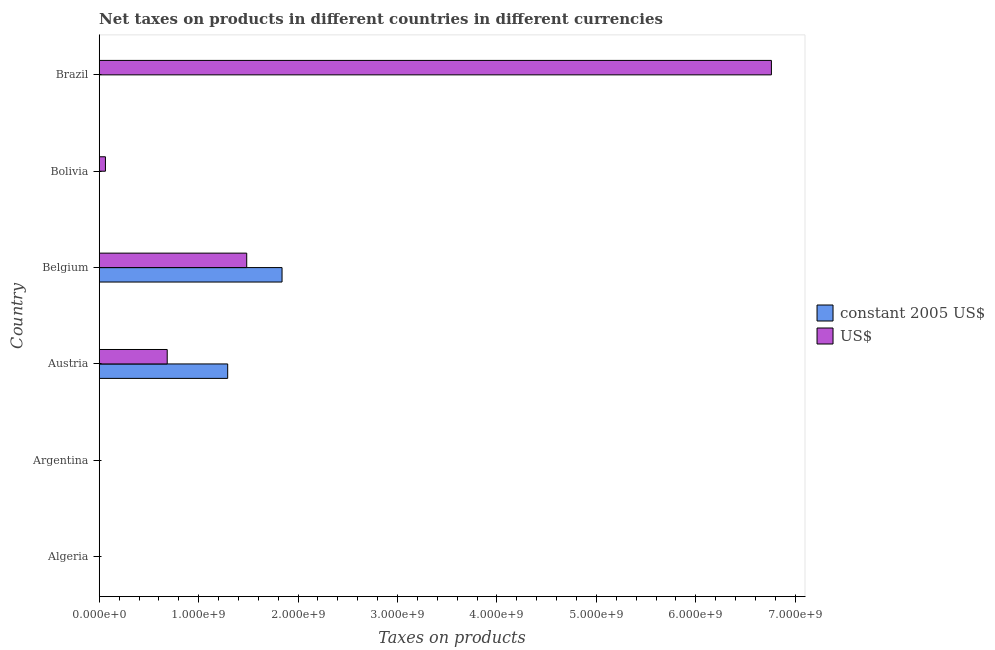Are the number of bars per tick equal to the number of legend labels?
Give a very brief answer. No. Are the number of bars on each tick of the Y-axis equal?
Offer a very short reply. No. How many bars are there on the 6th tick from the bottom?
Your answer should be compact. 2. What is the label of the 1st group of bars from the top?
Offer a very short reply. Brazil. What is the net taxes in constant 2005 us$ in Belgium?
Give a very brief answer. 1.84e+09. Across all countries, what is the maximum net taxes in us$?
Your response must be concise. 6.76e+09. What is the total net taxes in us$ in the graph?
Make the answer very short. 8.99e+09. What is the difference between the net taxes in us$ in Belgium and that in Bolivia?
Provide a succinct answer. 1.42e+09. What is the difference between the net taxes in us$ in Brazil and the net taxes in constant 2005 us$ in Algeria?
Make the answer very short. 6.76e+09. What is the average net taxes in constant 2005 us$ per country?
Offer a terse response. 5.22e+08. What is the difference between the net taxes in constant 2005 us$ and net taxes in us$ in Brazil?
Keep it short and to the point. -6.76e+09. What is the ratio of the net taxes in constant 2005 us$ in Belgium to that in Brazil?
Your response must be concise. 1.63e+11. Is the difference between the net taxes in us$ in Bolivia and Brazil greater than the difference between the net taxes in constant 2005 us$ in Bolivia and Brazil?
Your answer should be compact. No. What is the difference between the highest and the second highest net taxes in us$?
Ensure brevity in your answer.  5.28e+09. What is the difference between the highest and the lowest net taxes in us$?
Your answer should be compact. 6.76e+09. Are all the bars in the graph horizontal?
Your answer should be very brief. Yes. How many countries are there in the graph?
Keep it short and to the point. 6. Where does the legend appear in the graph?
Make the answer very short. Center right. How many legend labels are there?
Provide a short and direct response. 2. How are the legend labels stacked?
Your answer should be compact. Vertical. What is the title of the graph?
Provide a succinct answer. Net taxes on products in different countries in different currencies. Does "Male population" appear as one of the legend labels in the graph?
Your answer should be very brief. No. What is the label or title of the X-axis?
Offer a very short reply. Taxes on products. What is the Taxes on products in constant 2005 US$ in Algeria?
Offer a very short reply. 0. What is the Taxes on products of constant 2005 US$ in Argentina?
Keep it short and to the point. 5.31e-8. What is the Taxes on products in US$ in Argentina?
Keep it short and to the point. 1397.37. What is the Taxes on products in constant 2005 US$ in Austria?
Your response must be concise. 1.29e+09. What is the Taxes on products of US$ in Austria?
Offer a terse response. 6.84e+08. What is the Taxes on products in constant 2005 US$ in Belgium?
Your answer should be compact. 1.84e+09. What is the Taxes on products in US$ in Belgium?
Keep it short and to the point. 1.48e+09. What is the Taxes on products in constant 2005 US$ in Bolivia?
Provide a succinct answer. 743. What is the Taxes on products in US$ in Bolivia?
Make the answer very short. 6.25e+07. What is the Taxes on products of constant 2005 US$ in Brazil?
Your answer should be compact. 0.01. What is the Taxes on products of US$ in Brazil?
Provide a short and direct response. 6.76e+09. Across all countries, what is the maximum Taxes on products in constant 2005 US$?
Your answer should be very brief. 1.84e+09. Across all countries, what is the maximum Taxes on products of US$?
Provide a short and direct response. 6.76e+09. What is the total Taxes on products of constant 2005 US$ in the graph?
Give a very brief answer. 3.13e+09. What is the total Taxes on products in US$ in the graph?
Your answer should be very brief. 8.99e+09. What is the difference between the Taxes on products of constant 2005 US$ in Argentina and that in Austria?
Your response must be concise. -1.29e+09. What is the difference between the Taxes on products in US$ in Argentina and that in Austria?
Provide a short and direct response. -6.84e+08. What is the difference between the Taxes on products of constant 2005 US$ in Argentina and that in Belgium?
Make the answer very short. -1.84e+09. What is the difference between the Taxes on products in US$ in Argentina and that in Belgium?
Offer a very short reply. -1.48e+09. What is the difference between the Taxes on products in constant 2005 US$ in Argentina and that in Bolivia?
Provide a succinct answer. -743. What is the difference between the Taxes on products in US$ in Argentina and that in Bolivia?
Your response must be concise. -6.25e+07. What is the difference between the Taxes on products of constant 2005 US$ in Argentina and that in Brazil?
Make the answer very short. -0.01. What is the difference between the Taxes on products of US$ in Argentina and that in Brazil?
Your response must be concise. -6.76e+09. What is the difference between the Taxes on products of constant 2005 US$ in Austria and that in Belgium?
Your answer should be compact. -5.47e+08. What is the difference between the Taxes on products of US$ in Austria and that in Belgium?
Your answer should be very brief. -8.00e+08. What is the difference between the Taxes on products in constant 2005 US$ in Austria and that in Bolivia?
Ensure brevity in your answer.  1.29e+09. What is the difference between the Taxes on products of US$ in Austria and that in Bolivia?
Your answer should be compact. 6.21e+08. What is the difference between the Taxes on products in constant 2005 US$ in Austria and that in Brazil?
Make the answer very short. 1.29e+09. What is the difference between the Taxes on products in US$ in Austria and that in Brazil?
Provide a succinct answer. -6.08e+09. What is the difference between the Taxes on products of constant 2005 US$ in Belgium and that in Bolivia?
Offer a terse response. 1.84e+09. What is the difference between the Taxes on products in US$ in Belgium and that in Bolivia?
Your answer should be very brief. 1.42e+09. What is the difference between the Taxes on products in constant 2005 US$ in Belgium and that in Brazil?
Offer a very short reply. 1.84e+09. What is the difference between the Taxes on products in US$ in Belgium and that in Brazil?
Make the answer very short. -5.28e+09. What is the difference between the Taxes on products of constant 2005 US$ in Bolivia and that in Brazil?
Make the answer very short. 742.99. What is the difference between the Taxes on products of US$ in Bolivia and that in Brazil?
Your response must be concise. -6.70e+09. What is the difference between the Taxes on products of constant 2005 US$ in Argentina and the Taxes on products of US$ in Austria?
Keep it short and to the point. -6.84e+08. What is the difference between the Taxes on products of constant 2005 US$ in Argentina and the Taxes on products of US$ in Belgium?
Offer a terse response. -1.48e+09. What is the difference between the Taxes on products of constant 2005 US$ in Argentina and the Taxes on products of US$ in Bolivia?
Ensure brevity in your answer.  -6.25e+07. What is the difference between the Taxes on products in constant 2005 US$ in Argentina and the Taxes on products in US$ in Brazil?
Keep it short and to the point. -6.76e+09. What is the difference between the Taxes on products in constant 2005 US$ in Austria and the Taxes on products in US$ in Belgium?
Offer a terse response. -1.91e+08. What is the difference between the Taxes on products of constant 2005 US$ in Austria and the Taxes on products of US$ in Bolivia?
Your response must be concise. 1.23e+09. What is the difference between the Taxes on products of constant 2005 US$ in Austria and the Taxes on products of US$ in Brazil?
Provide a succinct answer. -5.47e+09. What is the difference between the Taxes on products in constant 2005 US$ in Belgium and the Taxes on products in US$ in Bolivia?
Offer a terse response. 1.78e+09. What is the difference between the Taxes on products of constant 2005 US$ in Belgium and the Taxes on products of US$ in Brazil?
Make the answer very short. -4.92e+09. What is the difference between the Taxes on products in constant 2005 US$ in Bolivia and the Taxes on products in US$ in Brazil?
Your answer should be compact. -6.76e+09. What is the average Taxes on products of constant 2005 US$ per country?
Provide a short and direct response. 5.22e+08. What is the average Taxes on products in US$ per country?
Your answer should be very brief. 1.50e+09. What is the difference between the Taxes on products in constant 2005 US$ and Taxes on products in US$ in Argentina?
Your response must be concise. -1397.37. What is the difference between the Taxes on products of constant 2005 US$ and Taxes on products of US$ in Austria?
Your answer should be very brief. 6.08e+08. What is the difference between the Taxes on products of constant 2005 US$ and Taxes on products of US$ in Belgium?
Your response must be concise. 3.55e+08. What is the difference between the Taxes on products in constant 2005 US$ and Taxes on products in US$ in Bolivia?
Provide a short and direct response. -6.25e+07. What is the difference between the Taxes on products of constant 2005 US$ and Taxes on products of US$ in Brazil?
Your response must be concise. -6.76e+09. What is the ratio of the Taxes on products in constant 2005 US$ in Argentina to that in Austria?
Ensure brevity in your answer.  0. What is the ratio of the Taxes on products of US$ in Argentina to that in Austria?
Keep it short and to the point. 0. What is the ratio of the Taxes on products of US$ in Argentina to that in Belgium?
Give a very brief answer. 0. What is the ratio of the Taxes on products of US$ in Argentina to that in Bolivia?
Offer a terse response. 0. What is the ratio of the Taxes on products in constant 2005 US$ in Argentina to that in Brazil?
Your answer should be compact. 0. What is the ratio of the Taxes on products of US$ in Argentina to that in Brazil?
Keep it short and to the point. 0. What is the ratio of the Taxes on products in constant 2005 US$ in Austria to that in Belgium?
Give a very brief answer. 0.7. What is the ratio of the Taxes on products of US$ in Austria to that in Belgium?
Offer a terse response. 0.46. What is the ratio of the Taxes on products of constant 2005 US$ in Austria to that in Bolivia?
Provide a short and direct response. 1.74e+06. What is the ratio of the Taxes on products in US$ in Austria to that in Bolivia?
Provide a short and direct response. 10.93. What is the ratio of the Taxes on products of constant 2005 US$ in Austria to that in Brazil?
Your response must be concise. 1.14e+11. What is the ratio of the Taxes on products of US$ in Austria to that in Brazil?
Your answer should be very brief. 0.1. What is the ratio of the Taxes on products in constant 2005 US$ in Belgium to that in Bolivia?
Keep it short and to the point. 2.47e+06. What is the ratio of the Taxes on products in US$ in Belgium to that in Bolivia?
Provide a succinct answer. 23.72. What is the ratio of the Taxes on products of constant 2005 US$ in Belgium to that in Brazil?
Provide a succinct answer. 1.63e+11. What is the ratio of the Taxes on products in US$ in Belgium to that in Brazil?
Provide a short and direct response. 0.22. What is the ratio of the Taxes on products of constant 2005 US$ in Bolivia to that in Brazil?
Your answer should be very brief. 6.58e+04. What is the ratio of the Taxes on products in US$ in Bolivia to that in Brazil?
Make the answer very short. 0.01. What is the difference between the highest and the second highest Taxes on products in constant 2005 US$?
Ensure brevity in your answer.  5.47e+08. What is the difference between the highest and the second highest Taxes on products in US$?
Ensure brevity in your answer.  5.28e+09. What is the difference between the highest and the lowest Taxes on products in constant 2005 US$?
Offer a terse response. 1.84e+09. What is the difference between the highest and the lowest Taxes on products of US$?
Offer a very short reply. 6.76e+09. 